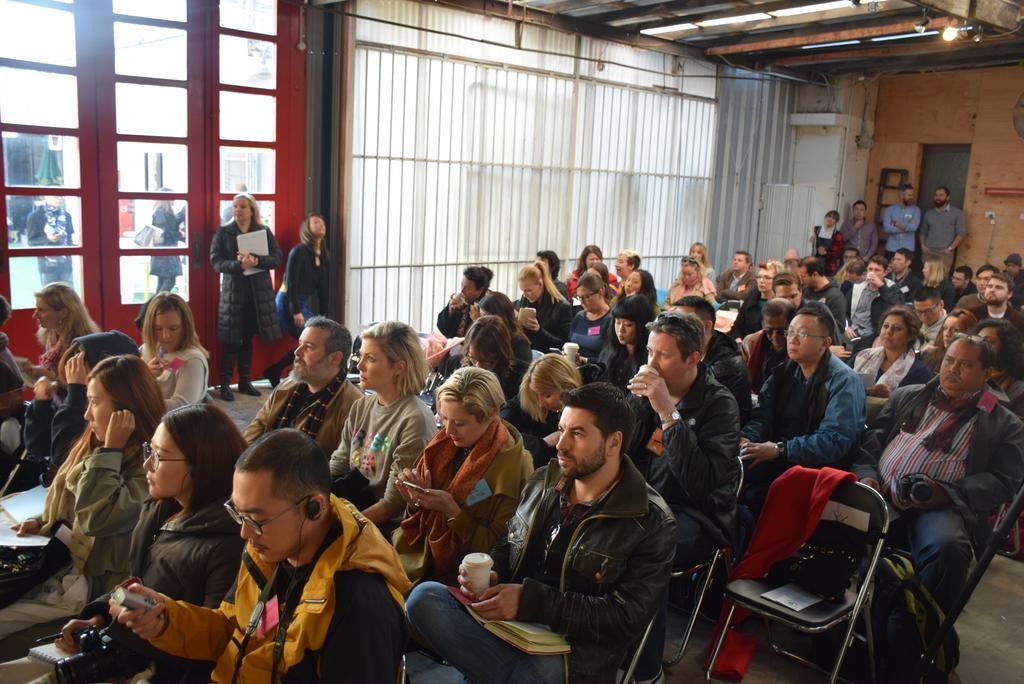Please provide a concise description of this image. There are few people here both men and women sitting on the chair. In the background there is a wall and few people standing. There is a door through window glass we can see people outside the room. On the roof top there is a light. 